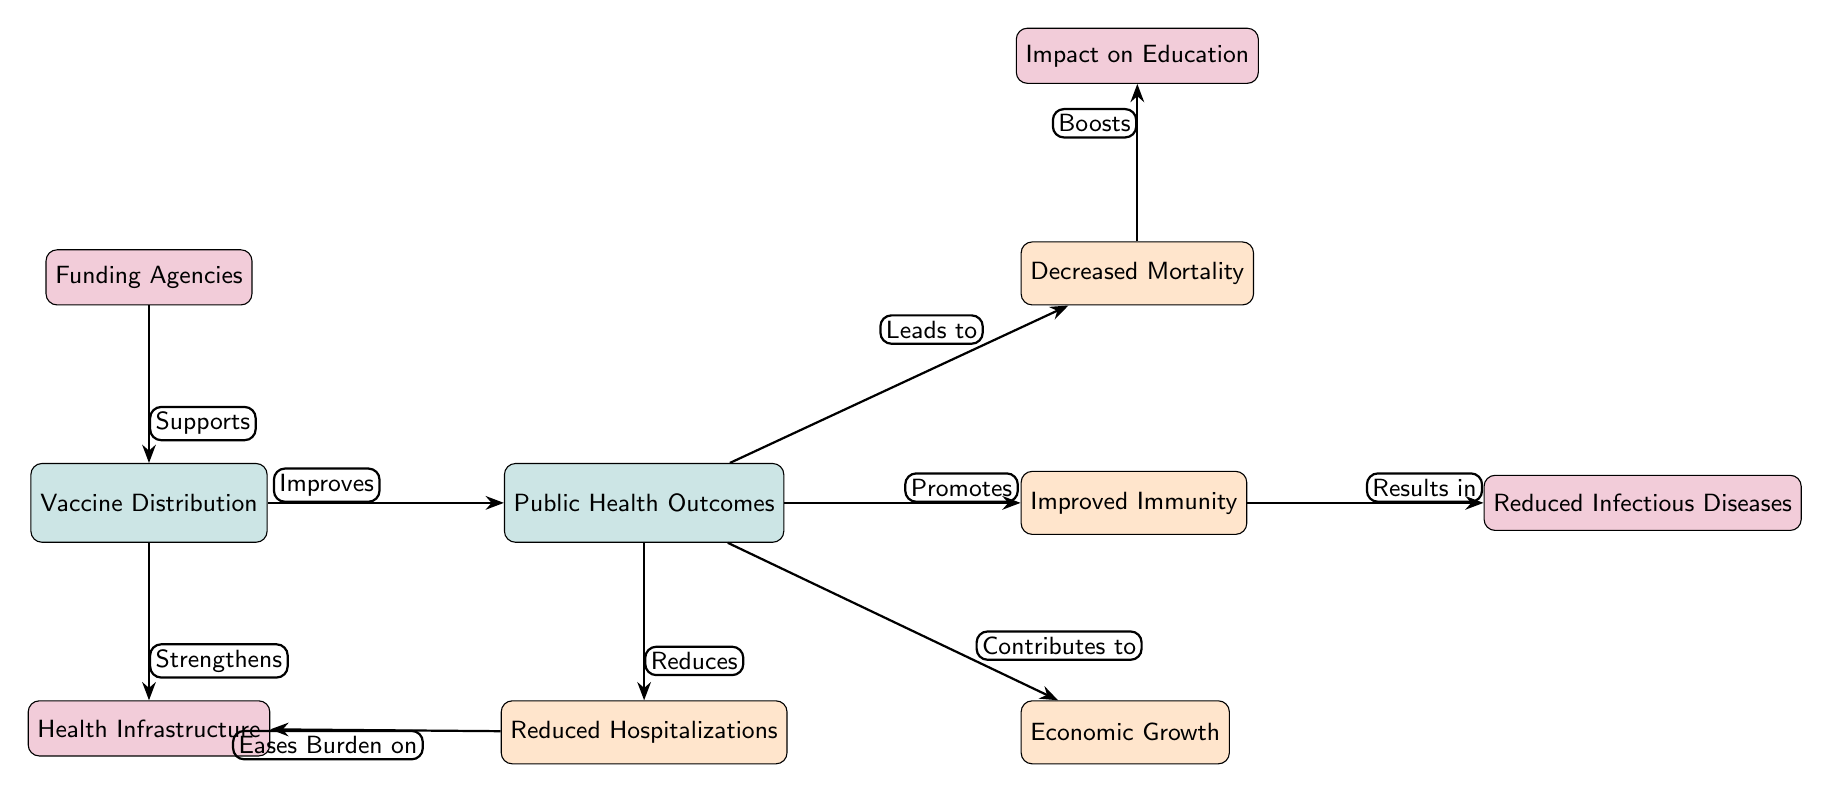What does Vaccine Distribution improve? The diagram indicates a direct connection from "Vaccine Distribution" to "Public Health Outcomes" with the label "Improves" showing that vaccination improves health outcomes.
Answer: Public Health Outcomes What are the secondary outcomes of public health mentioned in the diagram? The diagram lists four secondary outcomes of public health outcomes, which are directly connected to it. These are "Decreased Mortality," "Improved Immunity," "Economic Growth," and "Reduced Hospitalizations."
Answer: Four What leads to decreased mortality according to the diagram? The arrow from "Public Health Outcomes" to "Decreased Mortality" with the label "Leads to" indicates that improved public health outcomes will decrease mortality rates.
Answer: Public Health Outcomes Which node has the label "Eases Burden on" connected to it? Checking the flow of edges, the label "Eases Burden on" points to "Health Infrastructure," which indicates that reduced hospitalizations can help alleviate pressure on health infrastructure.
Answer: Health Infrastructure How many tertiary nodes are there in the diagram? There are three tertiary nodes related to the main concept of vaccine distribution. Counting them yields: "Funding Agencies," "Health Infrastructure," and "Reduced Infectious Diseases."
Answer: Three What supports Vaccine Distribution according to the diagram? The diagram features "Funding Agencies" connected to "Vaccine Distribution" with the label "Supports," implying that funding agencies facilitate the distribution of vaccines.
Answer: Funding Agencies What does Improved Immunity result in? The flow from "Improved Immunity" leads to "Reduced Infectious Diseases," labeled with "Results in." This indicates that enhancing immunity results in fewer infectious diseases.
Answer: Reduced Infectious Diseases Which secondary outcome contributes to economic growth? The label "Contributes to" from "Public Health Outcomes" to "Economic Growth" shows that improvements in public health support economic development.
Answer: Economic Growth What strengthens health infrastructure in the diagram? The "Strengthens" label connects from "Vaccine Distribution" to "Health Infrastructure," indicating that an increase in vaccine distribution bolsters health infrastructure.
Answer: Health Infrastructure 